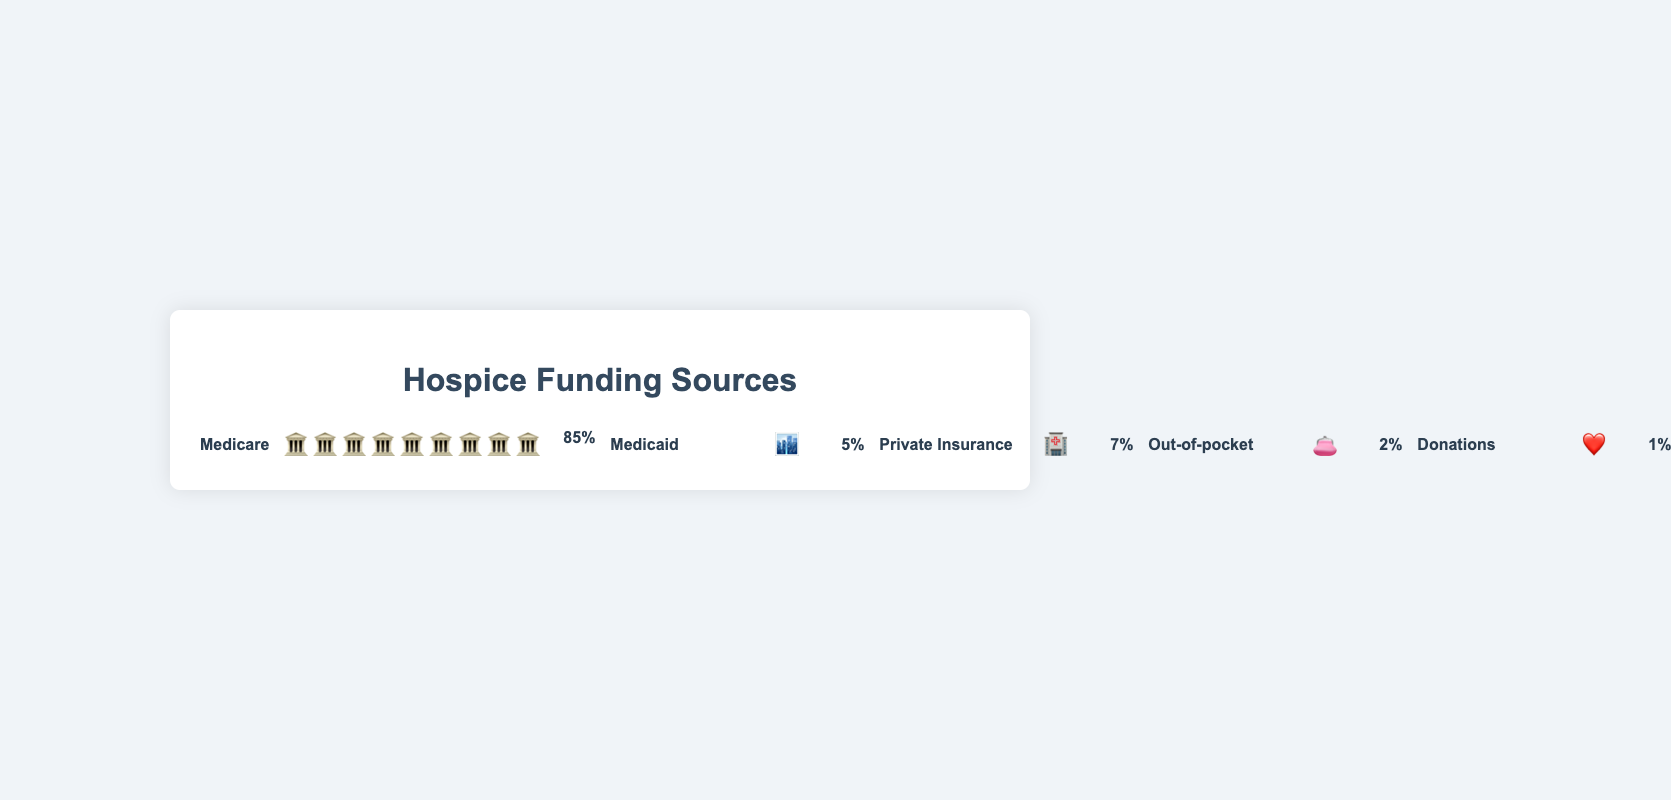what is the largest source of hospice funding? The largest source can be identified by the highest percentage value. Medicare has the highest funding percentage of 85%.
Answer: Medicare which funding source has the lowest percentage? The funding source with the lowest percentage is Donations, at 1%.
Answer: Donations how much more funding does Medicare provide compared to Medicaid? To find the difference between Medicare and Medicaid, subtract the Medicaid percentage (5%) from the Medicare percentage (85%). Hence, 85% - 5% equals 80%.
Answer: 80% what is the combined percentage of Private Insurance and Out-of-Pocket funding? Sum the percentages of Private Insurance (7%) and Out-of-Pocket (2%), resulting in 7% + 2% = 9%.
Answer: 9% what is the total percentage of government-based funding? Government-based funding includes Medicare (85%) and Medicaid (5%). Add these percentages: 85% + 5% = 90%.
Answer: 90% which icon represents Medicaid, and how many of them are displayed? The icon for Medicaid is a building (🏙️), and there is one icon displayed.
Answer: building (1) how many donation icons are shown in the figure? There is one donation icon (❤️) shown in the figure.
Answer: 1 rank the funding sources from highest to lowest percentage. Listing the funding percentages from highest to lowest: Medicare (85%), Private Insurance (7%), Medicaid (5%), Out-of-Pocket (2%), Donations (1%).
Answer: Medicare, Private Insurance, Medicaid, Out-of-Pocket, Donations how many more icons does Medicare have compared to Out-of-pocket? Medicare has 9 icons, and Out-of-pocket has 2 icons. The difference is 9 - 2 = 7 icons.
Answer: 7 what percentage of the funding is not provided by Medicare? Subtract the Medicare percentage (85%) from 100% to find the remaining funding percentage: 100% - 85% = 15%.
Answer: 15% 